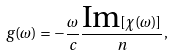Convert formula to latex. <formula><loc_0><loc_0><loc_500><loc_500>g ( \omega ) = - \frac { \omega } { c } \frac { \text {Im} [ \chi ( \omega ) ] } { n } ,</formula> 